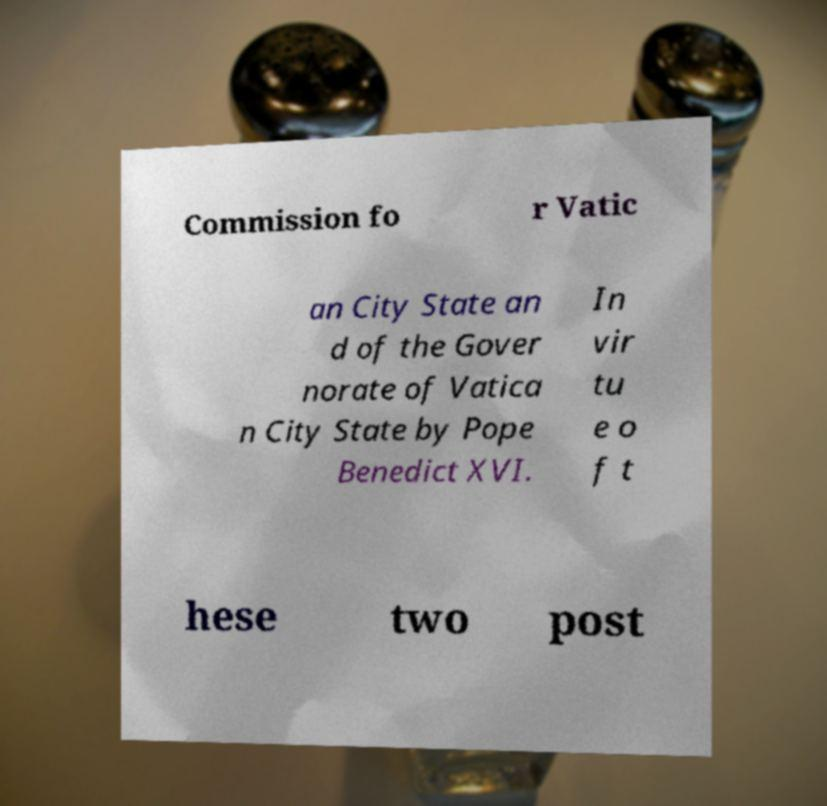Can you accurately transcribe the text from the provided image for me? Commission fo r Vatic an City State an d of the Gover norate of Vatica n City State by Pope Benedict XVI. In vir tu e o f t hese two post 